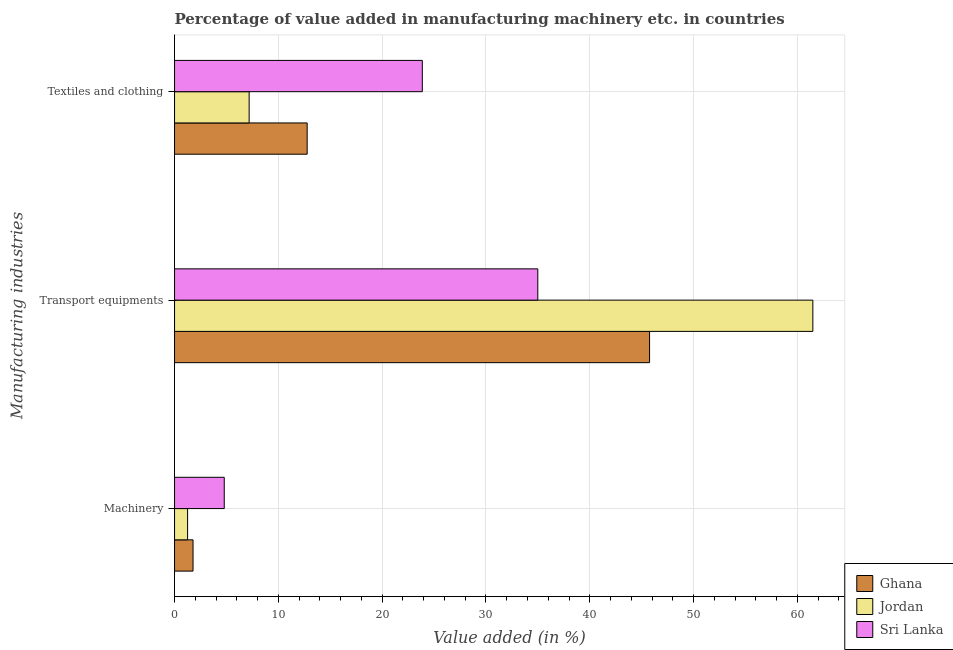Are the number of bars on each tick of the Y-axis equal?
Make the answer very short. Yes. How many bars are there on the 1st tick from the bottom?
Offer a very short reply. 3. What is the label of the 2nd group of bars from the top?
Give a very brief answer. Transport equipments. What is the value added in manufacturing transport equipments in Jordan?
Offer a very short reply. 61.49. Across all countries, what is the maximum value added in manufacturing textile and clothing?
Your answer should be compact. 23.87. Across all countries, what is the minimum value added in manufacturing transport equipments?
Your answer should be compact. 34.99. In which country was the value added in manufacturing textile and clothing maximum?
Offer a very short reply. Sri Lanka. In which country was the value added in manufacturing transport equipments minimum?
Ensure brevity in your answer.  Sri Lanka. What is the total value added in manufacturing textile and clothing in the graph?
Your response must be concise. 43.83. What is the difference between the value added in manufacturing machinery in Jordan and that in Sri Lanka?
Offer a terse response. -3.53. What is the difference between the value added in manufacturing textile and clothing in Jordan and the value added in manufacturing machinery in Ghana?
Your answer should be very brief. 5.4. What is the average value added in manufacturing machinery per country?
Make the answer very short. 2.61. What is the difference between the value added in manufacturing textile and clothing and value added in manufacturing machinery in Jordan?
Offer a very short reply. 5.93. What is the ratio of the value added in manufacturing transport equipments in Ghana to that in Sri Lanka?
Provide a short and direct response. 1.31. Is the value added in manufacturing machinery in Ghana less than that in Sri Lanka?
Keep it short and to the point. Yes. Is the difference between the value added in manufacturing transport equipments in Jordan and Sri Lanka greater than the difference between the value added in manufacturing machinery in Jordan and Sri Lanka?
Keep it short and to the point. Yes. What is the difference between the highest and the second highest value added in manufacturing textile and clothing?
Your response must be concise. 11.09. What is the difference between the highest and the lowest value added in manufacturing transport equipments?
Keep it short and to the point. 26.5. In how many countries, is the value added in manufacturing textile and clothing greater than the average value added in manufacturing textile and clothing taken over all countries?
Provide a succinct answer. 1. What does the 2nd bar from the top in Transport equipments represents?
Ensure brevity in your answer.  Jordan. What is the difference between two consecutive major ticks on the X-axis?
Ensure brevity in your answer.  10. How many legend labels are there?
Provide a succinct answer. 3. What is the title of the graph?
Give a very brief answer. Percentage of value added in manufacturing machinery etc. in countries. What is the label or title of the X-axis?
Ensure brevity in your answer.  Value added (in %). What is the label or title of the Y-axis?
Provide a succinct answer. Manufacturing industries. What is the Value added (in %) in Ghana in Machinery?
Offer a very short reply. 1.78. What is the Value added (in %) in Jordan in Machinery?
Ensure brevity in your answer.  1.26. What is the Value added (in %) in Sri Lanka in Machinery?
Ensure brevity in your answer.  4.79. What is the Value added (in %) in Ghana in Transport equipments?
Offer a very short reply. 45.76. What is the Value added (in %) of Jordan in Transport equipments?
Make the answer very short. 61.49. What is the Value added (in %) in Sri Lanka in Transport equipments?
Your answer should be compact. 34.99. What is the Value added (in %) of Ghana in Textiles and clothing?
Provide a short and direct response. 12.78. What is the Value added (in %) of Jordan in Textiles and clothing?
Provide a succinct answer. 7.19. What is the Value added (in %) of Sri Lanka in Textiles and clothing?
Your response must be concise. 23.87. Across all Manufacturing industries, what is the maximum Value added (in %) in Ghana?
Give a very brief answer. 45.76. Across all Manufacturing industries, what is the maximum Value added (in %) of Jordan?
Your response must be concise. 61.49. Across all Manufacturing industries, what is the maximum Value added (in %) of Sri Lanka?
Provide a succinct answer. 34.99. Across all Manufacturing industries, what is the minimum Value added (in %) of Ghana?
Your response must be concise. 1.78. Across all Manufacturing industries, what is the minimum Value added (in %) in Jordan?
Your response must be concise. 1.26. Across all Manufacturing industries, what is the minimum Value added (in %) of Sri Lanka?
Ensure brevity in your answer.  4.79. What is the total Value added (in %) of Ghana in the graph?
Your answer should be very brief. 60.31. What is the total Value added (in %) of Jordan in the graph?
Offer a very short reply. 69.93. What is the total Value added (in %) in Sri Lanka in the graph?
Your answer should be very brief. 63.65. What is the difference between the Value added (in %) in Ghana in Machinery and that in Transport equipments?
Keep it short and to the point. -43.98. What is the difference between the Value added (in %) of Jordan in Machinery and that in Transport equipments?
Your answer should be compact. -60.23. What is the difference between the Value added (in %) in Sri Lanka in Machinery and that in Transport equipments?
Give a very brief answer. -30.2. What is the difference between the Value added (in %) of Ghana in Machinery and that in Textiles and clothing?
Provide a succinct answer. -10.99. What is the difference between the Value added (in %) of Jordan in Machinery and that in Textiles and clothing?
Make the answer very short. -5.93. What is the difference between the Value added (in %) of Sri Lanka in Machinery and that in Textiles and clothing?
Provide a succinct answer. -19.08. What is the difference between the Value added (in %) of Ghana in Transport equipments and that in Textiles and clothing?
Keep it short and to the point. 32.98. What is the difference between the Value added (in %) in Jordan in Transport equipments and that in Textiles and clothing?
Make the answer very short. 54.3. What is the difference between the Value added (in %) in Sri Lanka in Transport equipments and that in Textiles and clothing?
Make the answer very short. 11.12. What is the difference between the Value added (in %) in Ghana in Machinery and the Value added (in %) in Jordan in Transport equipments?
Provide a succinct answer. -59.71. What is the difference between the Value added (in %) of Ghana in Machinery and the Value added (in %) of Sri Lanka in Transport equipments?
Offer a terse response. -33.21. What is the difference between the Value added (in %) in Jordan in Machinery and the Value added (in %) in Sri Lanka in Transport equipments?
Give a very brief answer. -33.74. What is the difference between the Value added (in %) in Ghana in Machinery and the Value added (in %) in Jordan in Textiles and clothing?
Offer a very short reply. -5.4. What is the difference between the Value added (in %) in Ghana in Machinery and the Value added (in %) in Sri Lanka in Textiles and clothing?
Ensure brevity in your answer.  -22.09. What is the difference between the Value added (in %) in Jordan in Machinery and the Value added (in %) in Sri Lanka in Textiles and clothing?
Make the answer very short. -22.61. What is the difference between the Value added (in %) in Ghana in Transport equipments and the Value added (in %) in Jordan in Textiles and clothing?
Provide a short and direct response. 38.57. What is the difference between the Value added (in %) of Ghana in Transport equipments and the Value added (in %) of Sri Lanka in Textiles and clothing?
Keep it short and to the point. 21.89. What is the difference between the Value added (in %) of Jordan in Transport equipments and the Value added (in %) of Sri Lanka in Textiles and clothing?
Provide a succinct answer. 37.62. What is the average Value added (in %) in Ghana per Manufacturing industries?
Give a very brief answer. 20.11. What is the average Value added (in %) in Jordan per Manufacturing industries?
Ensure brevity in your answer.  23.31. What is the average Value added (in %) of Sri Lanka per Manufacturing industries?
Your answer should be compact. 21.22. What is the difference between the Value added (in %) of Ghana and Value added (in %) of Jordan in Machinery?
Offer a very short reply. 0.52. What is the difference between the Value added (in %) in Ghana and Value added (in %) in Sri Lanka in Machinery?
Keep it short and to the point. -3.01. What is the difference between the Value added (in %) of Jordan and Value added (in %) of Sri Lanka in Machinery?
Keep it short and to the point. -3.53. What is the difference between the Value added (in %) in Ghana and Value added (in %) in Jordan in Transport equipments?
Make the answer very short. -15.73. What is the difference between the Value added (in %) of Ghana and Value added (in %) of Sri Lanka in Transport equipments?
Keep it short and to the point. 10.77. What is the difference between the Value added (in %) in Jordan and Value added (in %) in Sri Lanka in Transport equipments?
Your answer should be very brief. 26.5. What is the difference between the Value added (in %) of Ghana and Value added (in %) of Jordan in Textiles and clothing?
Your response must be concise. 5.59. What is the difference between the Value added (in %) in Ghana and Value added (in %) in Sri Lanka in Textiles and clothing?
Keep it short and to the point. -11.09. What is the difference between the Value added (in %) in Jordan and Value added (in %) in Sri Lanka in Textiles and clothing?
Offer a very short reply. -16.68. What is the ratio of the Value added (in %) in Ghana in Machinery to that in Transport equipments?
Ensure brevity in your answer.  0.04. What is the ratio of the Value added (in %) of Jordan in Machinery to that in Transport equipments?
Keep it short and to the point. 0.02. What is the ratio of the Value added (in %) in Sri Lanka in Machinery to that in Transport equipments?
Provide a succinct answer. 0.14. What is the ratio of the Value added (in %) in Ghana in Machinery to that in Textiles and clothing?
Offer a terse response. 0.14. What is the ratio of the Value added (in %) of Jordan in Machinery to that in Textiles and clothing?
Your response must be concise. 0.17. What is the ratio of the Value added (in %) in Sri Lanka in Machinery to that in Textiles and clothing?
Keep it short and to the point. 0.2. What is the ratio of the Value added (in %) of Ghana in Transport equipments to that in Textiles and clothing?
Your answer should be compact. 3.58. What is the ratio of the Value added (in %) of Jordan in Transport equipments to that in Textiles and clothing?
Make the answer very short. 8.56. What is the ratio of the Value added (in %) of Sri Lanka in Transport equipments to that in Textiles and clothing?
Provide a short and direct response. 1.47. What is the difference between the highest and the second highest Value added (in %) in Ghana?
Your answer should be compact. 32.98. What is the difference between the highest and the second highest Value added (in %) in Jordan?
Offer a terse response. 54.3. What is the difference between the highest and the second highest Value added (in %) in Sri Lanka?
Your answer should be compact. 11.12. What is the difference between the highest and the lowest Value added (in %) of Ghana?
Give a very brief answer. 43.98. What is the difference between the highest and the lowest Value added (in %) of Jordan?
Ensure brevity in your answer.  60.23. What is the difference between the highest and the lowest Value added (in %) in Sri Lanka?
Offer a terse response. 30.2. 